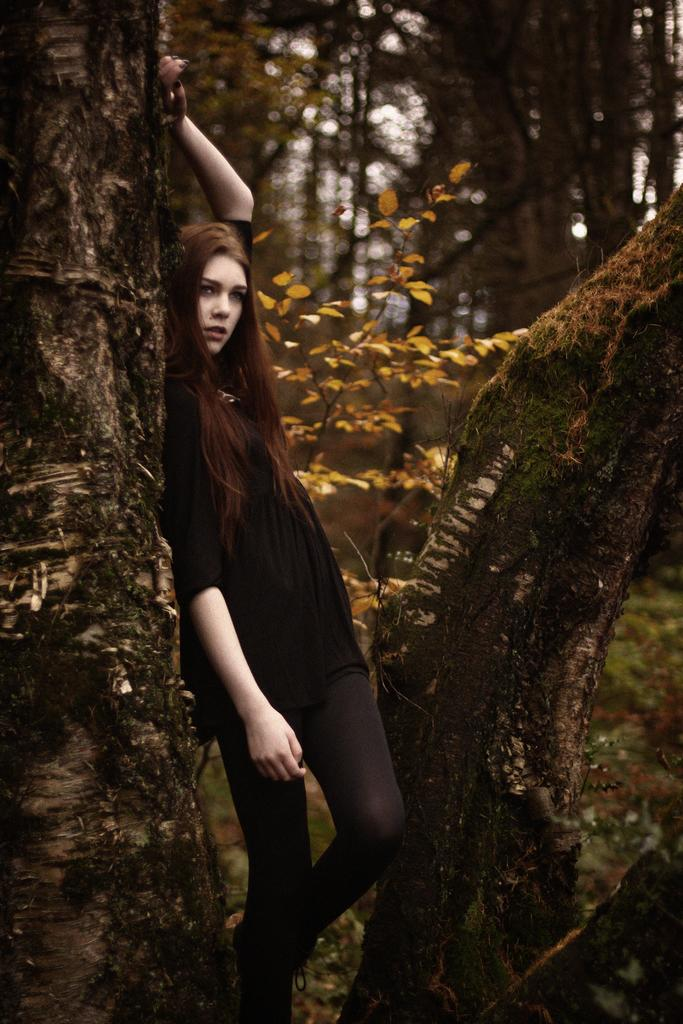Where was the image taken? The image was taken outdoors. What can be seen in the background of the image? There are many trees in the background of the image. Are the trees elevated or on the ground? The trees are on the ground. Who is the main subject in the image? A girl is standing in the middle of the image. What is the girl's position in relation to the ground? The girl is standing on the ground. How is the girl interacting with the trees? The girl is leaning on a tree. What type of alarm is attached to the tree in the image? There is no alarm present in the image; it features a girl leaning on a tree in an outdoor setting with many trees in the background. 